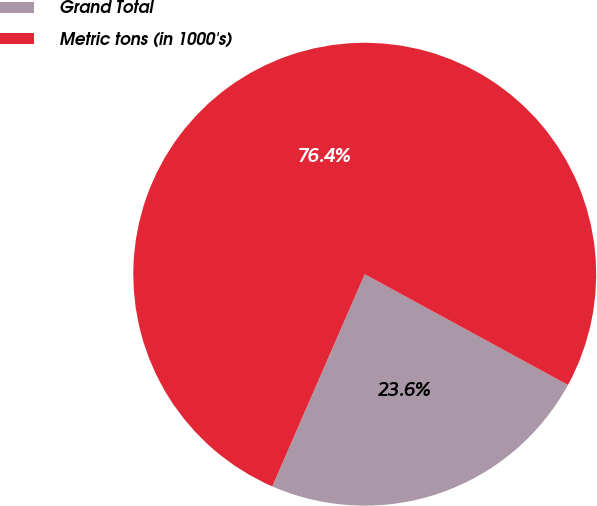Convert chart to OTSL. <chart><loc_0><loc_0><loc_500><loc_500><pie_chart><fcel>Grand Total<fcel>Metric tons (in 1000's)<nl><fcel>23.6%<fcel>76.4%<nl></chart> 